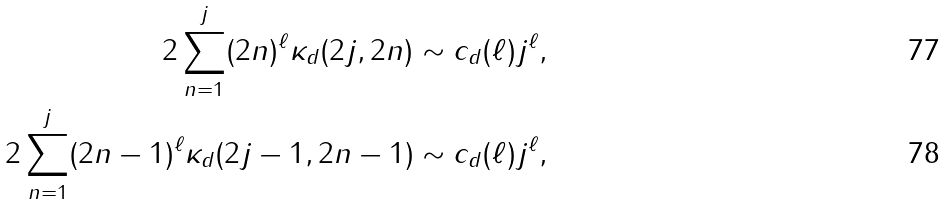<formula> <loc_0><loc_0><loc_500><loc_500>2 \sum _ { n = 1 } ^ { j } ( 2 n ) ^ { \ell } \kappa _ { d } ( 2 j , 2 n ) & \sim c _ { d } ( \ell ) j ^ { \ell } , \\ 2 \sum _ { n = 1 } ^ { j } ( 2 n - 1 ) ^ { \ell } \kappa _ { d } ( 2 j - 1 , 2 n - 1 ) & \sim c _ { d } ( \ell ) j ^ { \ell } ,</formula> 